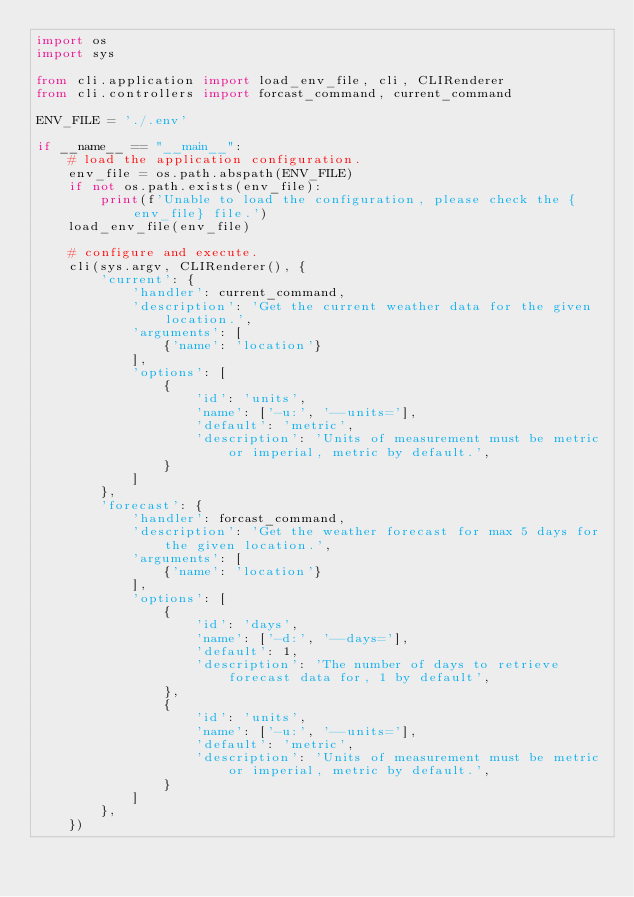<code> <loc_0><loc_0><loc_500><loc_500><_Python_>import os
import sys

from cli.application import load_env_file, cli, CLIRenderer
from cli.controllers import forcast_command, current_command

ENV_FILE = './.env'

if __name__ == "__main__":
    # load the application configuration.
    env_file = os.path.abspath(ENV_FILE)
    if not os.path.exists(env_file):
        print(f'Unable to load the configuration, please check the {env_file} file.')
    load_env_file(env_file)

    # configure and execute.
    cli(sys.argv, CLIRenderer(), {
        'current': {
            'handler': current_command,
            'description': 'Get the current weather data for the given location.',
            'arguments': [
                {'name': 'location'}
            ],
            'options': [
                {
                    'id': 'units',
                    'name': ['-u:', '--units='],
                    'default': 'metric',
                    'description': 'Units of measurement must be metric or imperial, metric by default.',
                }
            ]
        },
        'forecast': {
            'handler': forcast_command,
            'description': 'Get the weather forecast for max 5 days for the given location.',
            'arguments': [
                {'name': 'location'}
            ],
            'options': [
                {
                    'id': 'days',
                    'name': ['-d:', '--days='],
                    'default': 1,
                    'description': 'The number of days to retrieve forecast data for, 1 by default',
                },
                {
                    'id': 'units',
                    'name': ['-u:', '--units='],
                    'default': 'metric',
                    'description': 'Units of measurement must be metric or imperial, metric by default.',
                }
            ]
        },
    })
</code> 